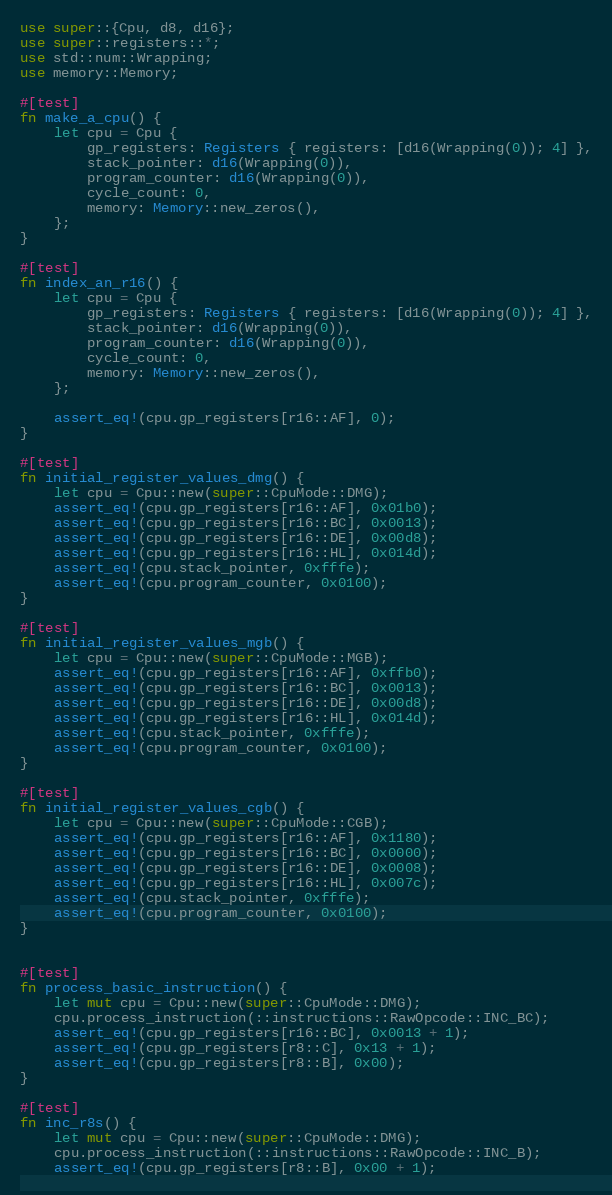Convert code to text. <code><loc_0><loc_0><loc_500><loc_500><_Rust_>use super::{Cpu, d8, d16};
use super::registers::*;
use std::num::Wrapping;
use memory::Memory;

#[test]
fn make_a_cpu() {
    let cpu = Cpu {
        gp_registers: Registers { registers: [d16(Wrapping(0)); 4] },
        stack_pointer: d16(Wrapping(0)),
        program_counter: d16(Wrapping(0)),
        cycle_count: 0,
        memory: Memory::new_zeros(),
    };
}

#[test]
fn index_an_r16() {
    let cpu = Cpu {
        gp_registers: Registers { registers: [d16(Wrapping(0)); 4] },
        stack_pointer: d16(Wrapping(0)),
        program_counter: d16(Wrapping(0)),
        cycle_count: 0,
        memory: Memory::new_zeros(),
    };

    assert_eq!(cpu.gp_registers[r16::AF], 0);
}

#[test]
fn initial_register_values_dmg() {
    let cpu = Cpu::new(super::CpuMode::DMG);
    assert_eq!(cpu.gp_registers[r16::AF], 0x01b0);
    assert_eq!(cpu.gp_registers[r16::BC], 0x0013);
    assert_eq!(cpu.gp_registers[r16::DE], 0x00d8);
    assert_eq!(cpu.gp_registers[r16::HL], 0x014d);
    assert_eq!(cpu.stack_pointer, 0xfffe);
    assert_eq!(cpu.program_counter, 0x0100);
}

#[test]
fn initial_register_values_mgb() {
    let cpu = Cpu::new(super::CpuMode::MGB);
    assert_eq!(cpu.gp_registers[r16::AF], 0xffb0);
    assert_eq!(cpu.gp_registers[r16::BC], 0x0013);
    assert_eq!(cpu.gp_registers[r16::DE], 0x00d8);
    assert_eq!(cpu.gp_registers[r16::HL], 0x014d);
    assert_eq!(cpu.stack_pointer, 0xfffe);
    assert_eq!(cpu.program_counter, 0x0100);
}

#[test]
fn initial_register_values_cgb() {
    let cpu = Cpu::new(super::CpuMode::CGB);
    assert_eq!(cpu.gp_registers[r16::AF], 0x1180);
    assert_eq!(cpu.gp_registers[r16::BC], 0x0000);
    assert_eq!(cpu.gp_registers[r16::DE], 0x0008);
    assert_eq!(cpu.gp_registers[r16::HL], 0x007c);
    assert_eq!(cpu.stack_pointer, 0xfffe);
    assert_eq!(cpu.program_counter, 0x0100);
}


#[test]
fn process_basic_instruction() {
    let mut cpu = Cpu::new(super::CpuMode::DMG);
    cpu.process_instruction(::instructions::RawOpcode::INC_BC);
    assert_eq!(cpu.gp_registers[r16::BC], 0x0013 + 1);
    assert_eq!(cpu.gp_registers[r8::C], 0x13 + 1);
    assert_eq!(cpu.gp_registers[r8::B], 0x00);
}

#[test]
fn inc_r8s() {
    let mut cpu = Cpu::new(super::CpuMode::DMG);
    cpu.process_instruction(::instructions::RawOpcode::INC_B);
    assert_eq!(cpu.gp_registers[r8::B], 0x00 + 1);</code> 